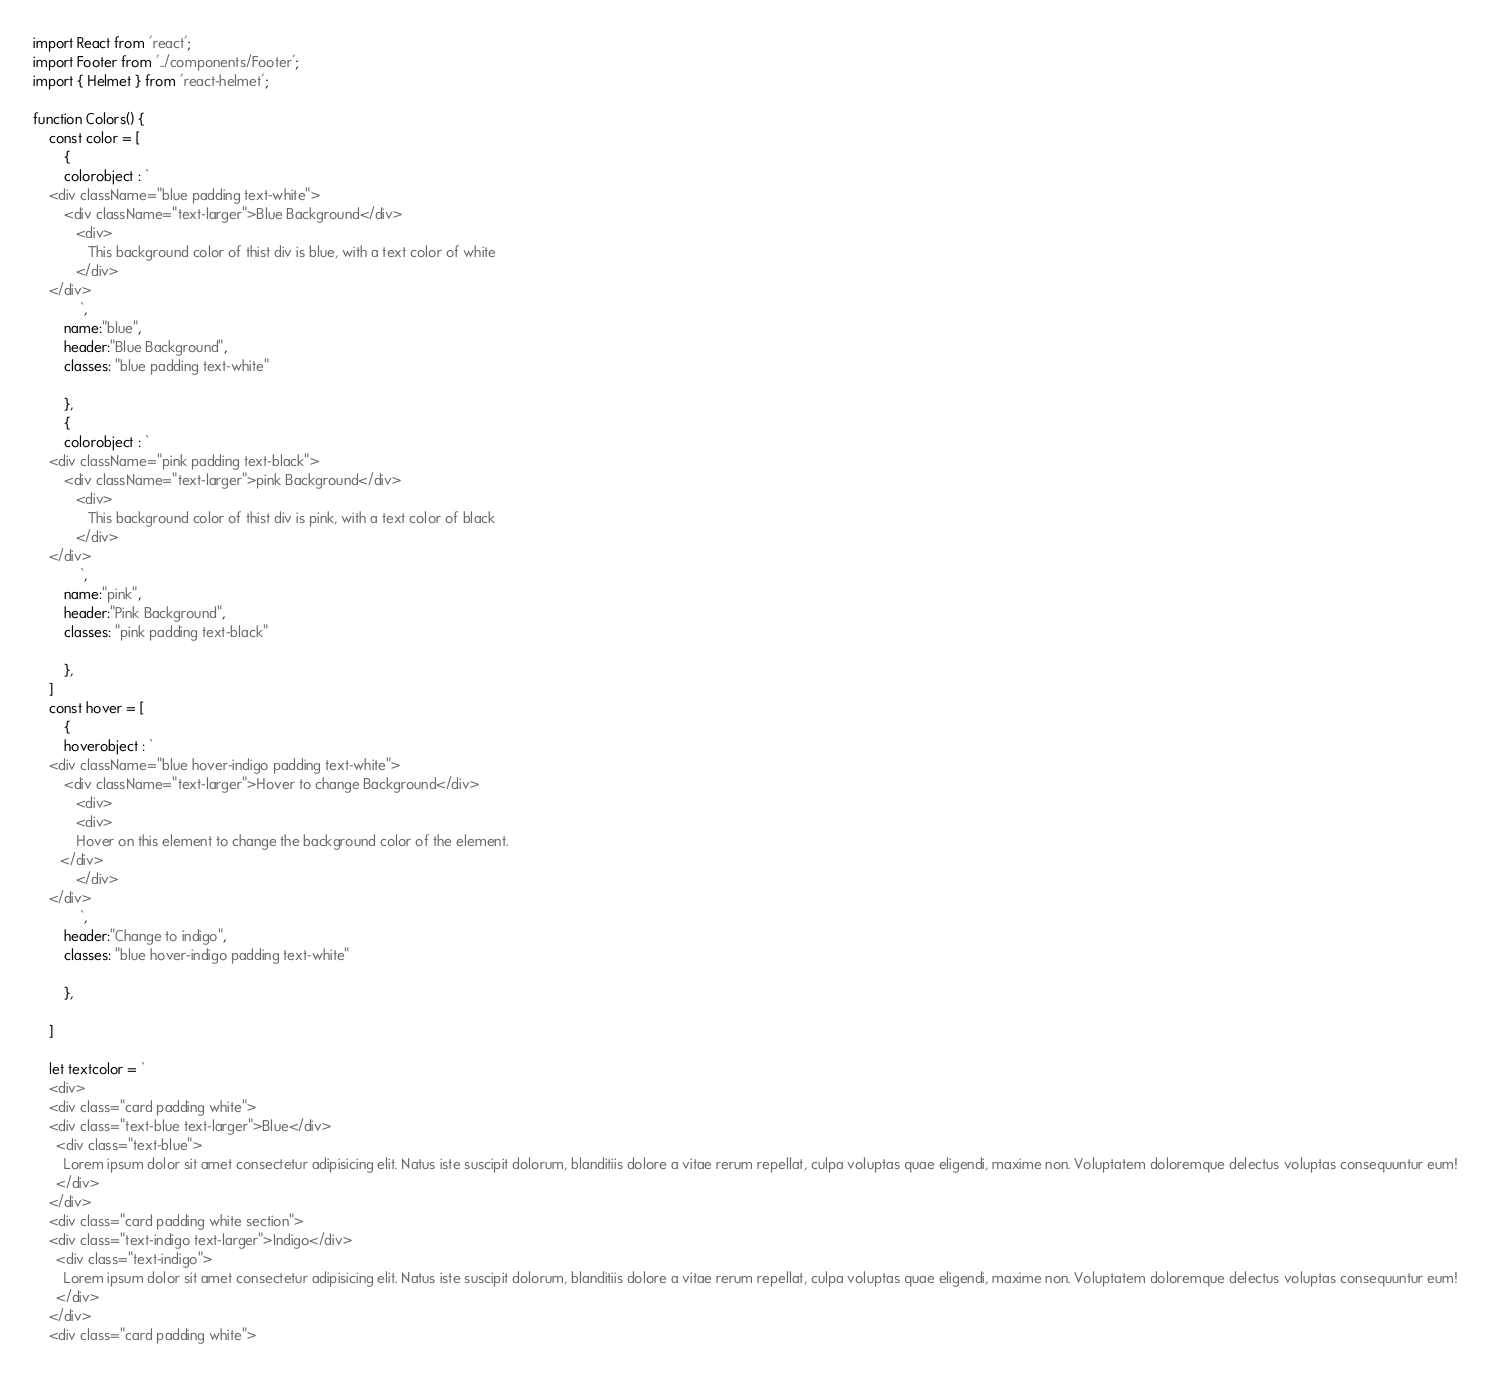Convert code to text. <code><loc_0><loc_0><loc_500><loc_500><_JavaScript_>import React from 'react';
import Footer from '../components/Footer';
import { Helmet } from 'react-helmet';

function Colors() {
    const color = [
        {
        colorobject : `
    <div className="blue padding text-white">
        <div className="text-larger">Blue Background</div>
           <div>
              This background color of thist div is blue, with a text color of white
           </div>
    </div>
            `,
        name:"blue",
        header:"Blue Background",
        classes: "blue padding text-white"

        },
        {
        colorobject : `
    <div className="pink padding text-black">
        <div className="text-larger">pink Background</div>
           <div>
              This background color of thist div is pink, with a text color of black
           </div>
    </div>
            `,
        name:"pink",
        header:"Pink Background",
        classes: "pink padding text-black"

        },
    ]
    const hover = [
        {
        hoverobject : `
    <div className="blue hover-indigo padding text-white">
        <div className="text-larger">Hover to change Background</div>
           <div>
           <div>
           Hover on this element to change the background color of the element.
       </div>
           </div>
    </div>
            `,
        header:"Change to indigo",
        classes: "blue hover-indigo padding text-white"

        },
 
    ]

    let textcolor = `
    <div>
    <div class="card padding white">
    <div class="text-blue text-larger">Blue</div>
      <div class="text-blue">
        Lorem ipsum dolor sit amet consectetur adipisicing elit. Natus iste suscipit dolorum, blanditiis dolore a vitae rerum repellat, culpa voluptas quae eligendi, maxime non. Voluptatem doloremque delectus voluptas consequuntur eum!
      </div>
    </div>
    <div class="card padding white section">
    <div class="text-indigo text-larger">Indigo</div>
      <div class="text-indigo">
        Lorem ipsum dolor sit amet consectetur adipisicing elit. Natus iste suscipit dolorum, blanditiis dolore a vitae rerum repellat, culpa voluptas quae eligendi, maxime non. Voluptatem doloremque delectus voluptas consequuntur eum!
      </div>
    </div>
    <div class="card padding white"></code> 